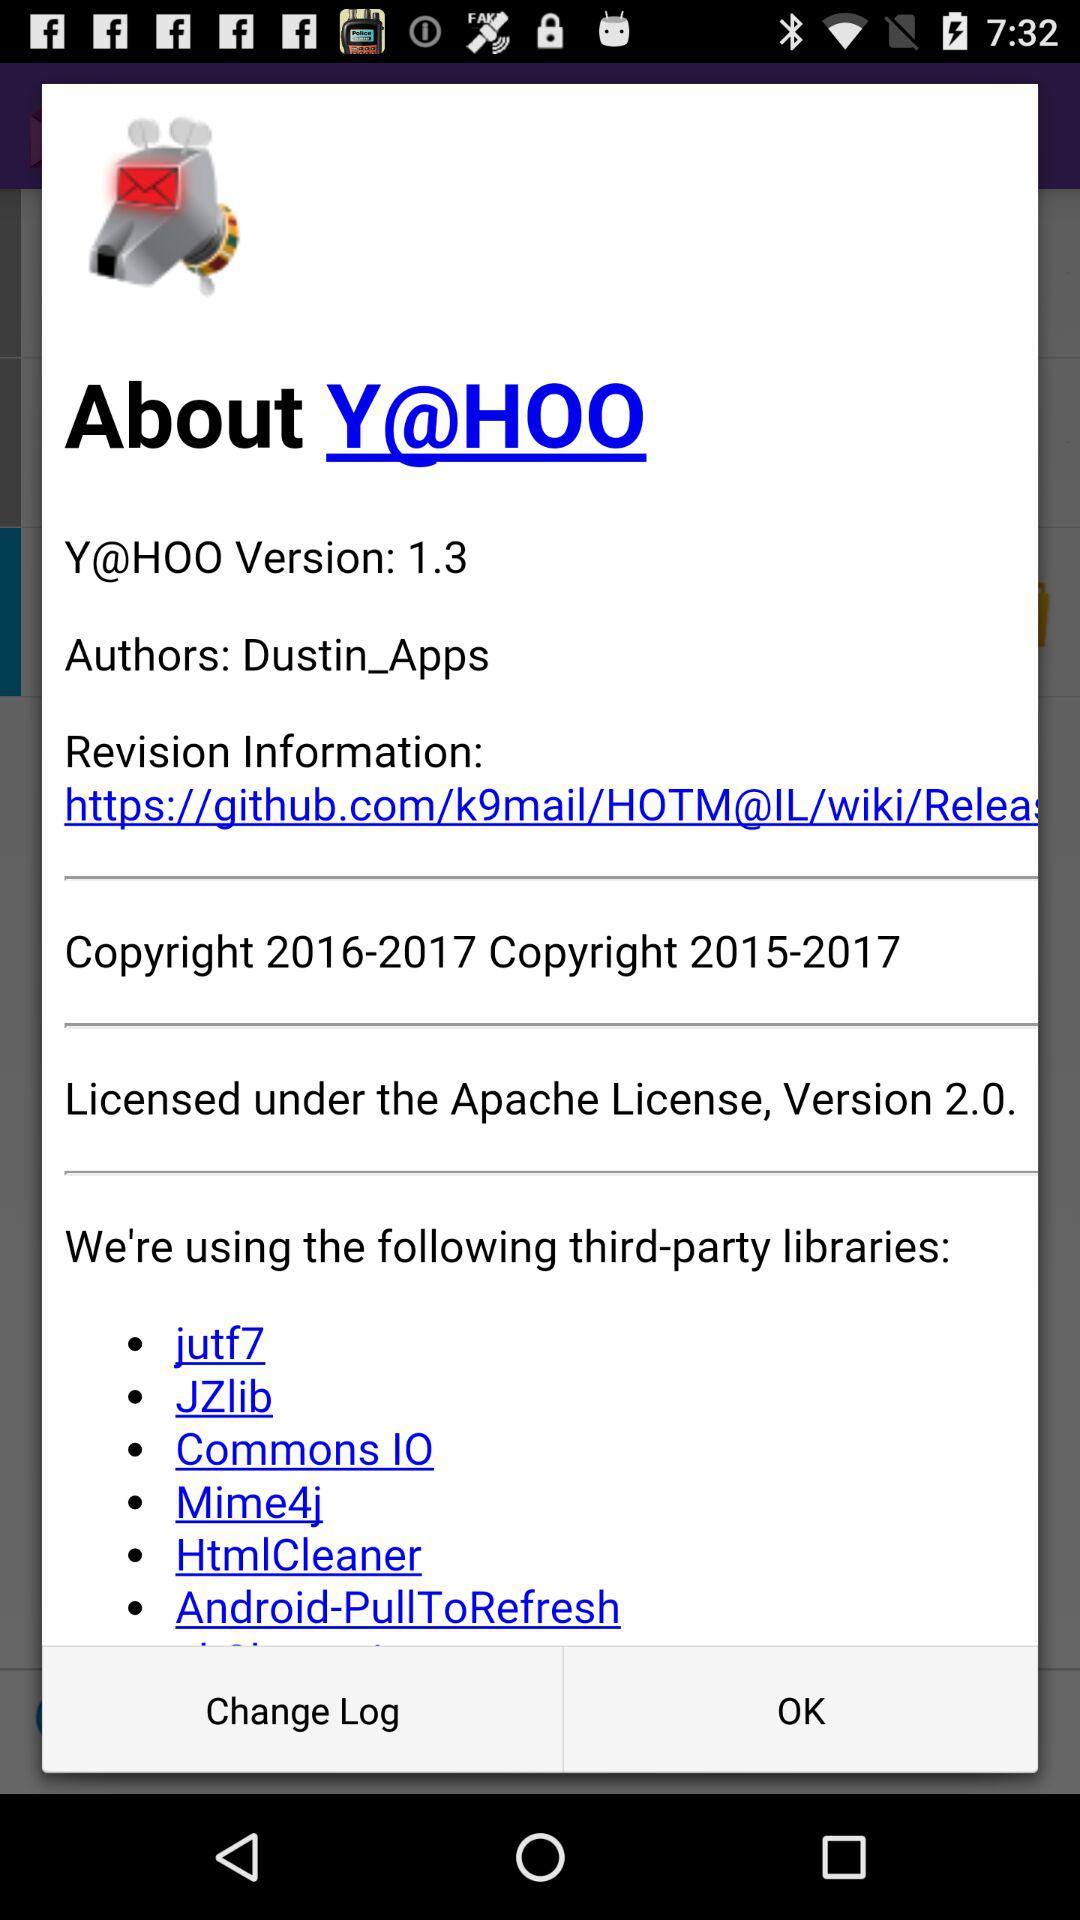Can you tell me more about the Apache License mentioned in the image? The Apache License, Version 2.0, is a permissive free software license written by the Apache Software Foundation. It allows users to use the software for any purpose, to distribute it, to modify it, and to distribute modified versions of the software under the terms of the license. 